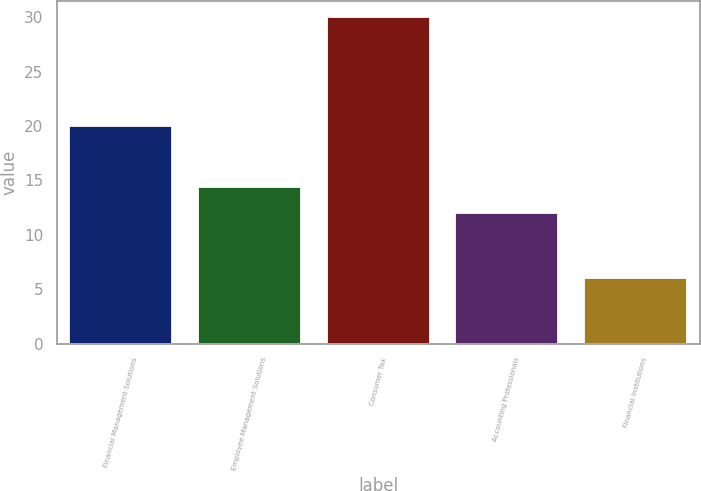Convert chart. <chart><loc_0><loc_0><loc_500><loc_500><bar_chart><fcel>Financial Management Solutions<fcel>Employee Management Solutions<fcel>Consumer Tax<fcel>Accounting Professionals<fcel>Financial Institutions<nl><fcel>20<fcel>14.4<fcel>30<fcel>12<fcel>6<nl></chart> 